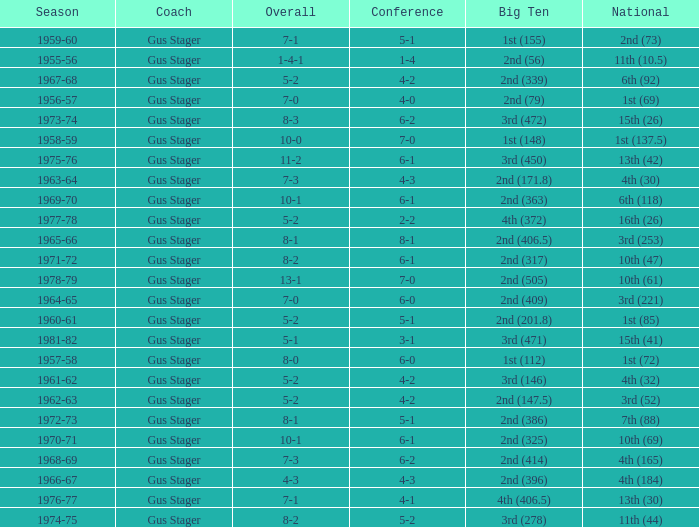What is the Coach with a Big Ten that is 2nd (79)? Gus Stager. 